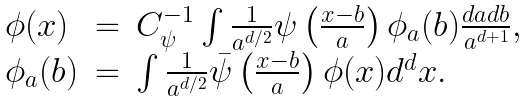<formula> <loc_0><loc_0><loc_500><loc_500>\begin{array} { l c l } \phi ( x ) & = & C _ { \psi } ^ { - 1 } \int \frac { 1 } { a ^ { d / 2 } } \psi \left ( \frac { x - b } { a } \right ) \phi _ { a } ( b ) \frac { d a d b } { a ^ { d + 1 } } , \\ \phi _ { a } ( b ) & = & \int \frac { 1 } { a ^ { d / 2 } } \bar { \psi } \left ( \frac { x - b } { a } \right ) \phi ( x ) d ^ { d } x . \end{array}</formula> 